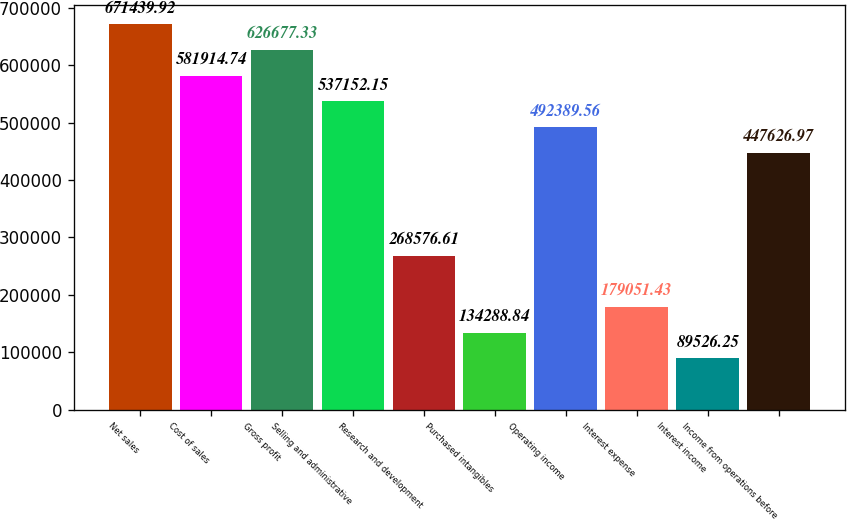Convert chart to OTSL. <chart><loc_0><loc_0><loc_500><loc_500><bar_chart><fcel>Net sales<fcel>Cost of sales<fcel>Gross profit<fcel>Selling and administrative<fcel>Research and development<fcel>Purchased intangibles<fcel>Operating income<fcel>Interest expense<fcel>Interest income<fcel>Income from operations before<nl><fcel>671440<fcel>581915<fcel>626677<fcel>537152<fcel>268577<fcel>134289<fcel>492390<fcel>179051<fcel>89526.2<fcel>447627<nl></chart> 